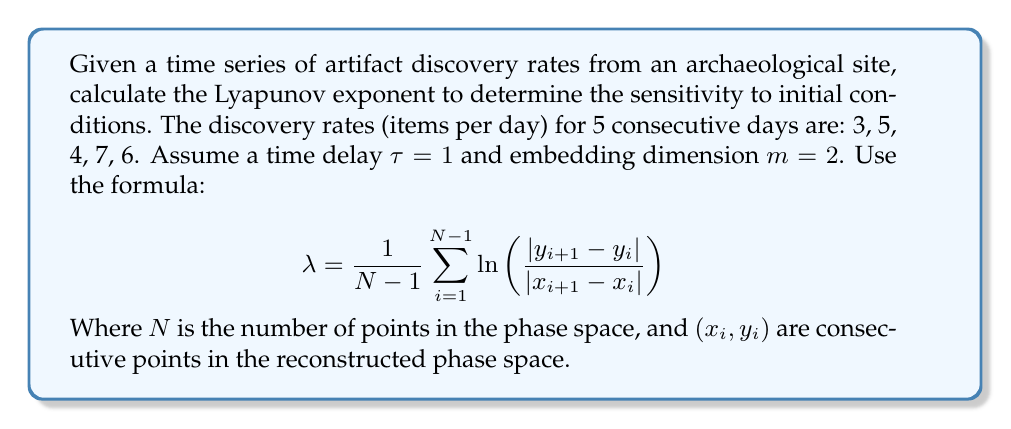Can you answer this question? To calculate the Lyapunov exponent for this time series, we'll follow these steps:

1. Reconstruct the phase space using time delay embedding:
   With τ = 1 and m = 2, we get:
   (3,5), (5,4), (4,7), (7,6)

2. Calculate the differences between consecutive points:
   $|x_2 - x_1| = |5 - 3| = 2$
   $|y_2 - y_1| = |4 - 5| = 1$
   $|x_3 - x_2| = |4 - 5| = 1$
   $|y_3 - y_2| = |7 - 4| = 3$
   $|x_4 - x_3| = |7 - 4| = 3$
   $|y_4 - y_3| = |6 - 7| = 1$

3. Apply the Lyapunov exponent formula:
   $$ λ = \frac{1}{3} \left( \ln \left(\frac{1}{2}\right) + \ln \left(\frac{3}{1}\right) + \ln \left(\frac{1}{3}\right) \right) $$

4. Simplify:
   $$ λ = \frac{1}{3} \left( -0.6931 + 1.0986 - 1.0986 \right) $$
   $$ λ = \frac{1}{3} (-0.6931) $$
   $$ λ ≈ -0.2310 $$

The negative Lyapunov exponent indicates that the system is not chaotic and tends towards a stable fixed point or periodic behavior.
Answer: $λ ≈ -0.2310$ 